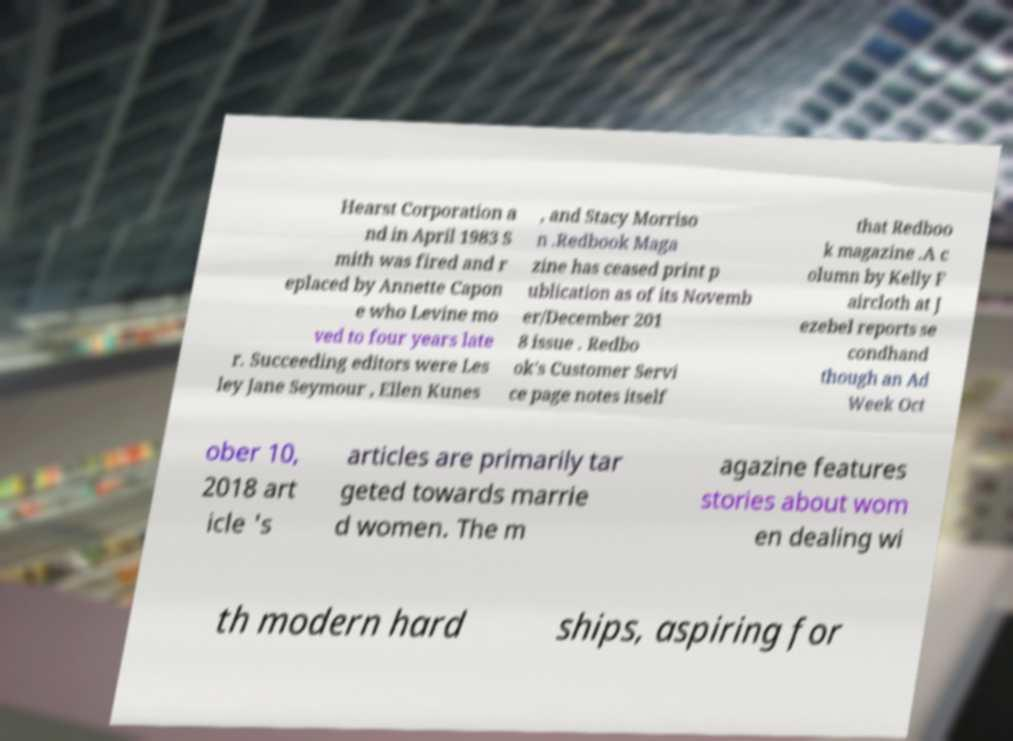Please identify and transcribe the text found in this image. Hearst Corporation a nd in April 1983 S mith was fired and r eplaced by Annette Capon e who Levine mo ved to four years late r. Succeeding editors were Les ley Jane Seymour , Ellen Kunes , and Stacy Morriso n .Redbook Maga zine has ceased print p ublication as of its Novemb er/December 201 8 issue . Redbo ok's Customer Servi ce page notes itself that Redboo k magazine .A c olumn by Kelly F aircloth at J ezebel reports se condhand though an Ad Week Oct ober 10, 2018 art icle 's articles are primarily tar geted towards marrie d women. The m agazine features stories about wom en dealing wi th modern hard ships, aspiring for 